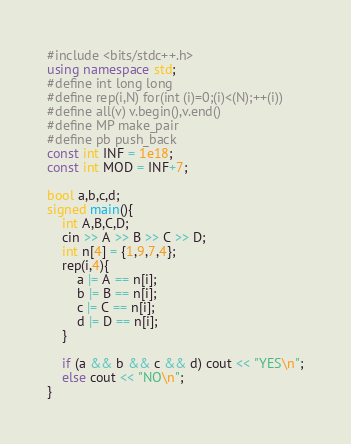Convert code to text. <code><loc_0><loc_0><loc_500><loc_500><_C++_>#include <bits/stdc++.h>
using namespace std;
#define int long long 
#define rep(i,N) for(int (i)=0;(i)<(N);++(i))
#define all(v) v.begin(),v.end()
#define MP make_pair
#define pb push_back
const int INF = 1e18;
const int MOD = INF+7;

bool a,b,c,d;
signed main(){
    int A,B,C,D;
    cin >> A >> B >> C >> D;
    int n[4] = {1,9,7,4};
    rep(i,4){
        a |= A == n[i];
        b |= B == n[i];
        c |= C == n[i];
        d |= D == n[i];
    }

    if (a && b && c && d) cout << "YES\n";
    else cout << "NO\n";
}</code> 